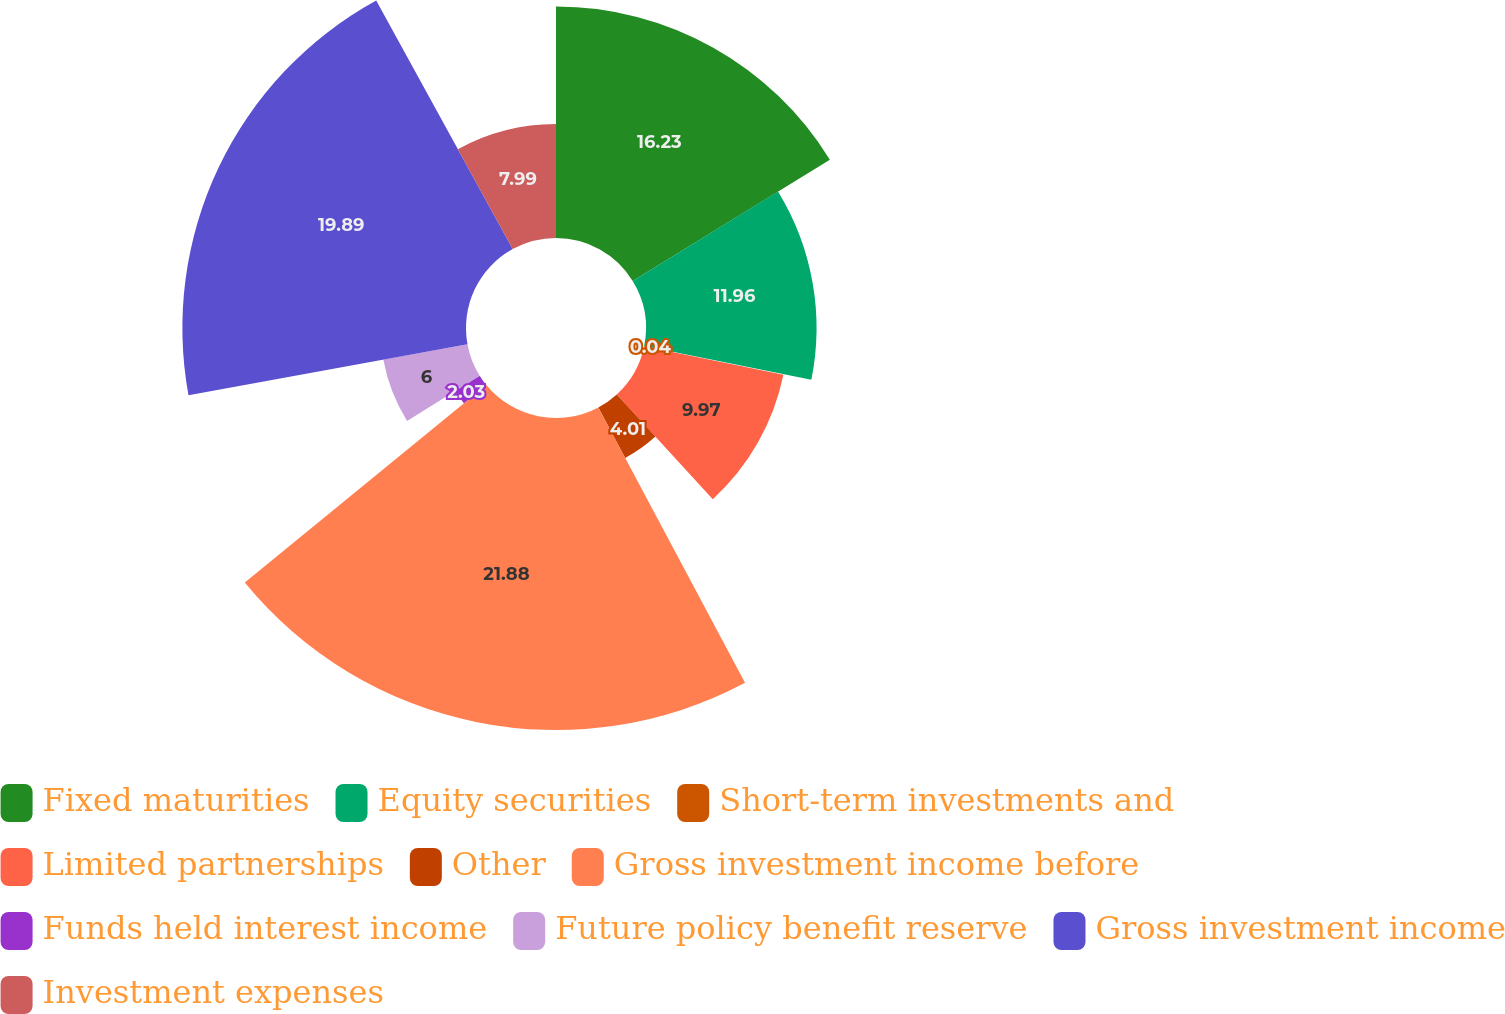Convert chart to OTSL. <chart><loc_0><loc_0><loc_500><loc_500><pie_chart><fcel>Fixed maturities<fcel>Equity securities<fcel>Short-term investments and<fcel>Limited partnerships<fcel>Other<fcel>Gross investment income before<fcel>Funds held interest income<fcel>Future policy benefit reserve<fcel>Gross investment income<fcel>Investment expenses<nl><fcel>16.23%<fcel>11.96%<fcel>0.04%<fcel>9.97%<fcel>4.01%<fcel>21.88%<fcel>2.03%<fcel>6.0%<fcel>19.89%<fcel>7.99%<nl></chart> 